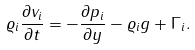Convert formula to latex. <formula><loc_0><loc_0><loc_500><loc_500>\varrho _ { i } \frac { \partial v _ { i } } { \partial t } = - \frac { \partial p _ { i } } { \partial y } - \varrho _ { i } { g } + \Gamma _ { i } .</formula> 